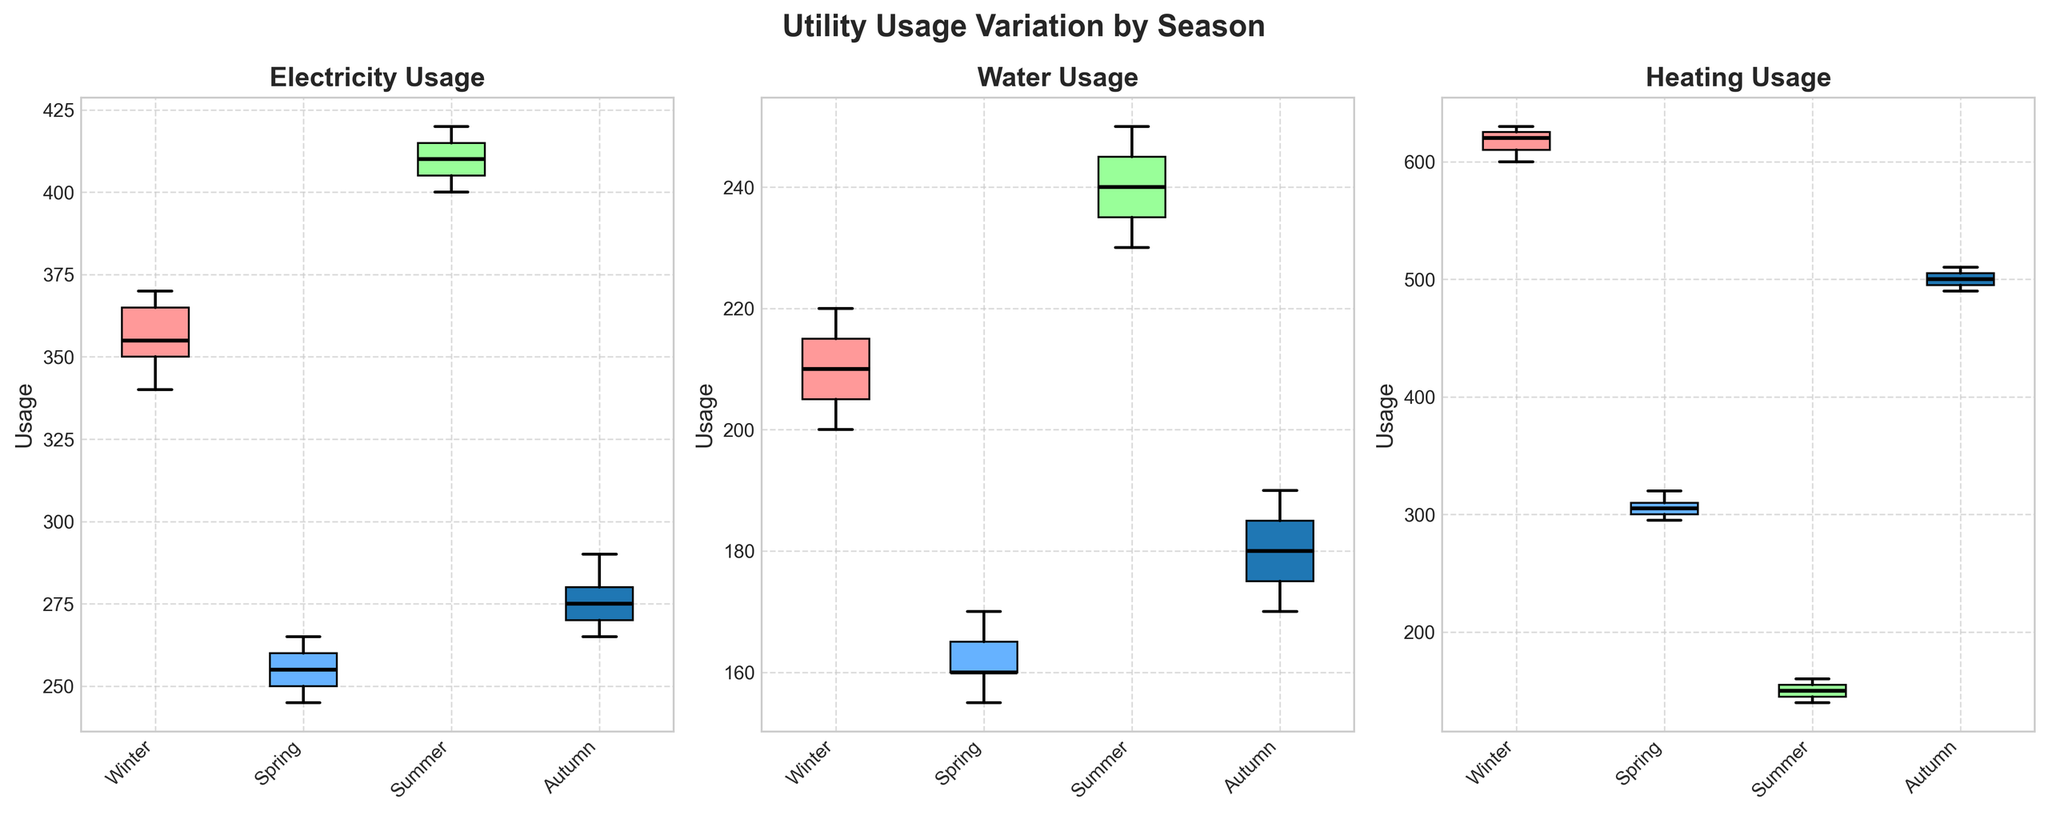What's the title of the overall figure? The title can be found at the top of the figure, which has been formatted in bold. It provides a clear indication of the subject of the subplots.
Answer: Utility Usage Variation by Season What types of utilities are compared in the figure? The types of utilities compared are specified in the titles of each subplot. Each subplot focuses on a different utility.
Answer: Electricity, Water, Heating Which season shows the highest median Electricity usage? First, locate the median lines (bold black lines) in the Electricity subplot. By comparing these lines across the seasons, the highest median can be identified.
Answer: Summer How does Water usage compare between Winter and Summer? By checking the median lines in the Water subplot for both Winter and Summer, we can directly compare their levels.
Answer: Higher in Summer Which season has the lowest variability in Heating usage? Variability can be assessed by the range between the whiskers in each box plot in the Heating subplot. The narrower the range, the lower the variability.
Answer: Summer What's the median Heating usage in Autumn? Locate the Heating subplot and check the bold black line within the Autumn box plot to determine the median value.
Answer: 500 In which season is the range of Electricity usage the widest? By examining the length of the whiskers and the interquartile range (box length) in the Electricity subplot, the season with the widest range of usage can be identified.
Answer: Summer Compare the median values of Water usage for Autumn and Spring and state which is higher. Locate the median lines in the Water subplot for Autumn and Spring and compare their positions to see which is higher.
Answer: Autumn Which utility shows the most significant seasonal variation in usage? To determine this, compare the spreads (ranges and interquartile ranges) across all seasons for each utility and identify the one with the largest differences.
Answer: Heating Is the usage of any utility nearly the same across all seasons? Look for the subplot where the boxes and whiskers show minimal differences in medians and ranges across all four seasons.
Answer: No 